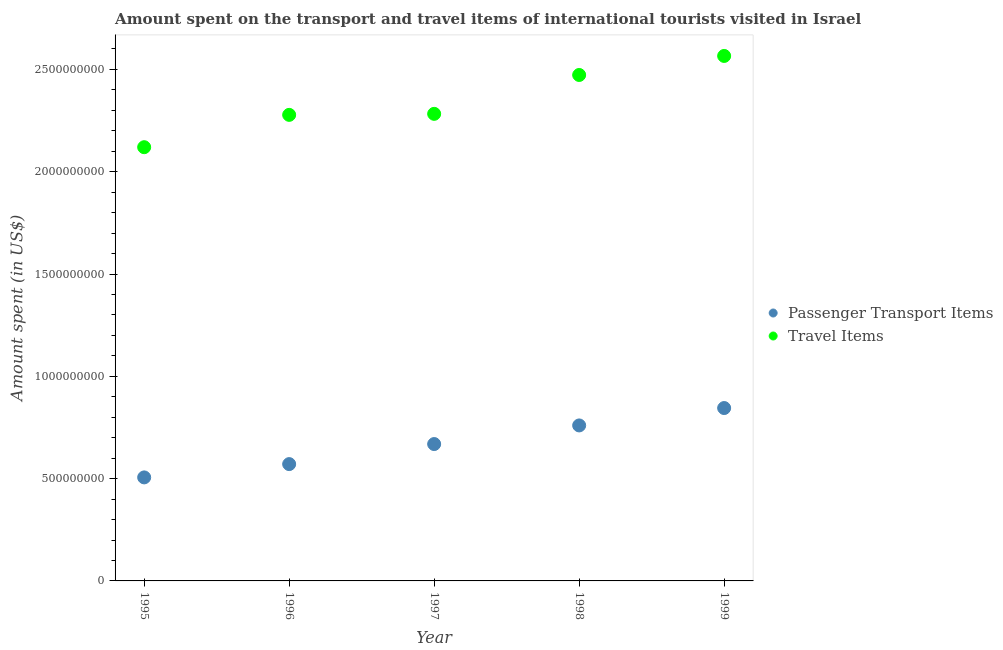How many different coloured dotlines are there?
Your answer should be very brief. 2. Is the number of dotlines equal to the number of legend labels?
Offer a very short reply. Yes. What is the amount spent on passenger transport items in 1996?
Your response must be concise. 5.71e+08. Across all years, what is the maximum amount spent on passenger transport items?
Provide a short and direct response. 8.45e+08. Across all years, what is the minimum amount spent on passenger transport items?
Offer a very short reply. 5.06e+08. In which year was the amount spent in travel items minimum?
Provide a succinct answer. 1995. What is the total amount spent on passenger transport items in the graph?
Offer a very short reply. 3.35e+09. What is the difference between the amount spent in travel items in 1995 and that in 1996?
Your answer should be compact. -1.58e+08. What is the difference between the amount spent in travel items in 1998 and the amount spent on passenger transport items in 1995?
Offer a terse response. 1.97e+09. What is the average amount spent in travel items per year?
Give a very brief answer. 2.34e+09. In the year 1999, what is the difference between the amount spent on passenger transport items and amount spent in travel items?
Provide a succinct answer. -1.72e+09. What is the ratio of the amount spent on passenger transport items in 1996 to that in 1999?
Give a very brief answer. 0.68. Is the amount spent in travel items in 1998 less than that in 1999?
Give a very brief answer. Yes. What is the difference between the highest and the second highest amount spent in travel items?
Offer a very short reply. 9.30e+07. What is the difference between the highest and the lowest amount spent in travel items?
Offer a very short reply. 4.46e+08. Does the amount spent in travel items monotonically increase over the years?
Offer a terse response. Yes. Is the amount spent on passenger transport items strictly less than the amount spent in travel items over the years?
Your response must be concise. Yes. How many dotlines are there?
Give a very brief answer. 2. How many years are there in the graph?
Your response must be concise. 5. Does the graph contain grids?
Give a very brief answer. No. How many legend labels are there?
Your response must be concise. 2. What is the title of the graph?
Keep it short and to the point. Amount spent on the transport and travel items of international tourists visited in Israel. Does "Canada" appear as one of the legend labels in the graph?
Ensure brevity in your answer.  No. What is the label or title of the X-axis?
Your response must be concise. Year. What is the label or title of the Y-axis?
Keep it short and to the point. Amount spent (in US$). What is the Amount spent (in US$) of Passenger Transport Items in 1995?
Your answer should be very brief. 5.06e+08. What is the Amount spent (in US$) of Travel Items in 1995?
Provide a succinct answer. 2.12e+09. What is the Amount spent (in US$) of Passenger Transport Items in 1996?
Offer a very short reply. 5.71e+08. What is the Amount spent (in US$) in Travel Items in 1996?
Ensure brevity in your answer.  2.28e+09. What is the Amount spent (in US$) of Passenger Transport Items in 1997?
Your response must be concise. 6.69e+08. What is the Amount spent (in US$) of Travel Items in 1997?
Provide a succinct answer. 2.28e+09. What is the Amount spent (in US$) in Passenger Transport Items in 1998?
Provide a succinct answer. 7.60e+08. What is the Amount spent (in US$) of Travel Items in 1998?
Your response must be concise. 2.47e+09. What is the Amount spent (in US$) of Passenger Transport Items in 1999?
Your answer should be very brief. 8.45e+08. What is the Amount spent (in US$) of Travel Items in 1999?
Give a very brief answer. 2.57e+09. Across all years, what is the maximum Amount spent (in US$) of Passenger Transport Items?
Your answer should be compact. 8.45e+08. Across all years, what is the maximum Amount spent (in US$) in Travel Items?
Ensure brevity in your answer.  2.57e+09. Across all years, what is the minimum Amount spent (in US$) in Passenger Transport Items?
Your answer should be very brief. 5.06e+08. Across all years, what is the minimum Amount spent (in US$) of Travel Items?
Offer a terse response. 2.12e+09. What is the total Amount spent (in US$) in Passenger Transport Items in the graph?
Your response must be concise. 3.35e+09. What is the total Amount spent (in US$) in Travel Items in the graph?
Offer a terse response. 1.17e+1. What is the difference between the Amount spent (in US$) in Passenger Transport Items in 1995 and that in 1996?
Your answer should be compact. -6.50e+07. What is the difference between the Amount spent (in US$) of Travel Items in 1995 and that in 1996?
Give a very brief answer. -1.58e+08. What is the difference between the Amount spent (in US$) of Passenger Transport Items in 1995 and that in 1997?
Your answer should be very brief. -1.63e+08. What is the difference between the Amount spent (in US$) in Travel Items in 1995 and that in 1997?
Ensure brevity in your answer.  -1.63e+08. What is the difference between the Amount spent (in US$) of Passenger Transport Items in 1995 and that in 1998?
Make the answer very short. -2.54e+08. What is the difference between the Amount spent (in US$) of Travel Items in 1995 and that in 1998?
Offer a terse response. -3.53e+08. What is the difference between the Amount spent (in US$) in Passenger Transport Items in 1995 and that in 1999?
Keep it short and to the point. -3.39e+08. What is the difference between the Amount spent (in US$) in Travel Items in 1995 and that in 1999?
Offer a terse response. -4.46e+08. What is the difference between the Amount spent (in US$) of Passenger Transport Items in 1996 and that in 1997?
Keep it short and to the point. -9.80e+07. What is the difference between the Amount spent (in US$) of Travel Items in 1996 and that in 1997?
Your answer should be compact. -5.00e+06. What is the difference between the Amount spent (in US$) in Passenger Transport Items in 1996 and that in 1998?
Your answer should be compact. -1.89e+08. What is the difference between the Amount spent (in US$) of Travel Items in 1996 and that in 1998?
Keep it short and to the point. -1.95e+08. What is the difference between the Amount spent (in US$) of Passenger Transport Items in 1996 and that in 1999?
Provide a short and direct response. -2.74e+08. What is the difference between the Amount spent (in US$) in Travel Items in 1996 and that in 1999?
Your response must be concise. -2.88e+08. What is the difference between the Amount spent (in US$) of Passenger Transport Items in 1997 and that in 1998?
Keep it short and to the point. -9.10e+07. What is the difference between the Amount spent (in US$) of Travel Items in 1997 and that in 1998?
Provide a short and direct response. -1.90e+08. What is the difference between the Amount spent (in US$) in Passenger Transport Items in 1997 and that in 1999?
Your response must be concise. -1.76e+08. What is the difference between the Amount spent (in US$) of Travel Items in 1997 and that in 1999?
Offer a very short reply. -2.83e+08. What is the difference between the Amount spent (in US$) in Passenger Transport Items in 1998 and that in 1999?
Keep it short and to the point. -8.50e+07. What is the difference between the Amount spent (in US$) of Travel Items in 1998 and that in 1999?
Provide a succinct answer. -9.30e+07. What is the difference between the Amount spent (in US$) of Passenger Transport Items in 1995 and the Amount spent (in US$) of Travel Items in 1996?
Keep it short and to the point. -1.77e+09. What is the difference between the Amount spent (in US$) in Passenger Transport Items in 1995 and the Amount spent (in US$) in Travel Items in 1997?
Ensure brevity in your answer.  -1.78e+09. What is the difference between the Amount spent (in US$) of Passenger Transport Items in 1995 and the Amount spent (in US$) of Travel Items in 1998?
Your response must be concise. -1.97e+09. What is the difference between the Amount spent (in US$) in Passenger Transport Items in 1995 and the Amount spent (in US$) in Travel Items in 1999?
Your answer should be very brief. -2.06e+09. What is the difference between the Amount spent (in US$) in Passenger Transport Items in 1996 and the Amount spent (in US$) in Travel Items in 1997?
Offer a terse response. -1.71e+09. What is the difference between the Amount spent (in US$) in Passenger Transport Items in 1996 and the Amount spent (in US$) in Travel Items in 1998?
Keep it short and to the point. -1.90e+09. What is the difference between the Amount spent (in US$) in Passenger Transport Items in 1996 and the Amount spent (in US$) in Travel Items in 1999?
Make the answer very short. -2.00e+09. What is the difference between the Amount spent (in US$) in Passenger Transport Items in 1997 and the Amount spent (in US$) in Travel Items in 1998?
Give a very brief answer. -1.80e+09. What is the difference between the Amount spent (in US$) in Passenger Transport Items in 1997 and the Amount spent (in US$) in Travel Items in 1999?
Keep it short and to the point. -1.90e+09. What is the difference between the Amount spent (in US$) in Passenger Transport Items in 1998 and the Amount spent (in US$) in Travel Items in 1999?
Ensure brevity in your answer.  -1.81e+09. What is the average Amount spent (in US$) of Passenger Transport Items per year?
Offer a very short reply. 6.70e+08. What is the average Amount spent (in US$) in Travel Items per year?
Offer a terse response. 2.34e+09. In the year 1995, what is the difference between the Amount spent (in US$) in Passenger Transport Items and Amount spent (in US$) in Travel Items?
Your answer should be compact. -1.61e+09. In the year 1996, what is the difference between the Amount spent (in US$) of Passenger Transport Items and Amount spent (in US$) of Travel Items?
Your answer should be very brief. -1.71e+09. In the year 1997, what is the difference between the Amount spent (in US$) of Passenger Transport Items and Amount spent (in US$) of Travel Items?
Give a very brief answer. -1.61e+09. In the year 1998, what is the difference between the Amount spent (in US$) of Passenger Transport Items and Amount spent (in US$) of Travel Items?
Ensure brevity in your answer.  -1.71e+09. In the year 1999, what is the difference between the Amount spent (in US$) of Passenger Transport Items and Amount spent (in US$) of Travel Items?
Your answer should be compact. -1.72e+09. What is the ratio of the Amount spent (in US$) in Passenger Transport Items in 1995 to that in 1996?
Keep it short and to the point. 0.89. What is the ratio of the Amount spent (in US$) of Travel Items in 1995 to that in 1996?
Ensure brevity in your answer.  0.93. What is the ratio of the Amount spent (in US$) of Passenger Transport Items in 1995 to that in 1997?
Your answer should be compact. 0.76. What is the ratio of the Amount spent (in US$) in Passenger Transport Items in 1995 to that in 1998?
Your answer should be very brief. 0.67. What is the ratio of the Amount spent (in US$) of Travel Items in 1995 to that in 1998?
Your response must be concise. 0.86. What is the ratio of the Amount spent (in US$) of Passenger Transport Items in 1995 to that in 1999?
Keep it short and to the point. 0.6. What is the ratio of the Amount spent (in US$) in Travel Items in 1995 to that in 1999?
Your answer should be very brief. 0.83. What is the ratio of the Amount spent (in US$) of Passenger Transport Items in 1996 to that in 1997?
Offer a terse response. 0.85. What is the ratio of the Amount spent (in US$) in Travel Items in 1996 to that in 1997?
Keep it short and to the point. 1. What is the ratio of the Amount spent (in US$) of Passenger Transport Items in 1996 to that in 1998?
Provide a succinct answer. 0.75. What is the ratio of the Amount spent (in US$) of Travel Items in 1996 to that in 1998?
Offer a very short reply. 0.92. What is the ratio of the Amount spent (in US$) of Passenger Transport Items in 1996 to that in 1999?
Your answer should be very brief. 0.68. What is the ratio of the Amount spent (in US$) in Travel Items in 1996 to that in 1999?
Provide a short and direct response. 0.89. What is the ratio of the Amount spent (in US$) of Passenger Transport Items in 1997 to that in 1998?
Keep it short and to the point. 0.88. What is the ratio of the Amount spent (in US$) of Travel Items in 1997 to that in 1998?
Your answer should be very brief. 0.92. What is the ratio of the Amount spent (in US$) of Passenger Transport Items in 1997 to that in 1999?
Keep it short and to the point. 0.79. What is the ratio of the Amount spent (in US$) of Travel Items in 1997 to that in 1999?
Give a very brief answer. 0.89. What is the ratio of the Amount spent (in US$) in Passenger Transport Items in 1998 to that in 1999?
Keep it short and to the point. 0.9. What is the ratio of the Amount spent (in US$) of Travel Items in 1998 to that in 1999?
Offer a terse response. 0.96. What is the difference between the highest and the second highest Amount spent (in US$) in Passenger Transport Items?
Offer a very short reply. 8.50e+07. What is the difference between the highest and the second highest Amount spent (in US$) of Travel Items?
Your response must be concise. 9.30e+07. What is the difference between the highest and the lowest Amount spent (in US$) in Passenger Transport Items?
Your answer should be compact. 3.39e+08. What is the difference between the highest and the lowest Amount spent (in US$) of Travel Items?
Ensure brevity in your answer.  4.46e+08. 